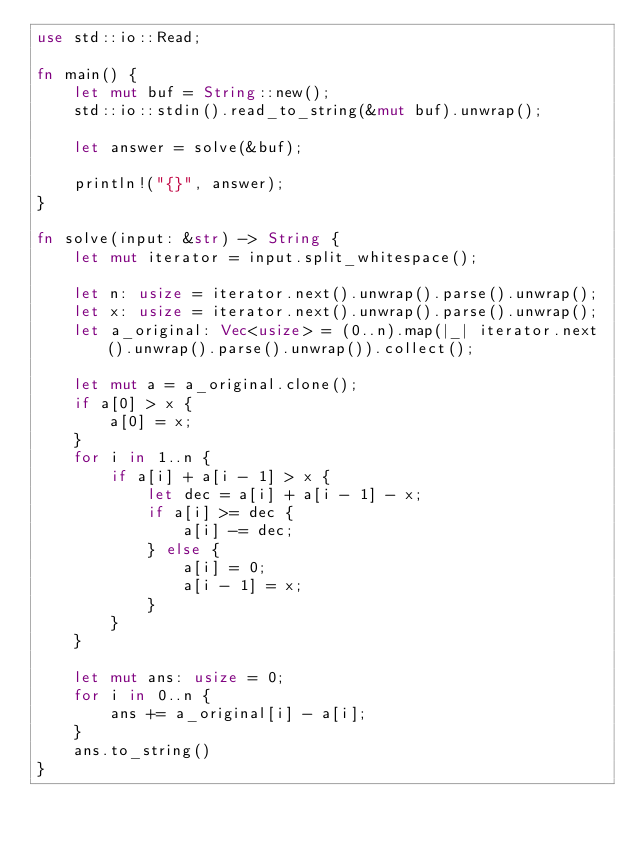Convert code to text. <code><loc_0><loc_0><loc_500><loc_500><_Rust_>use std::io::Read;

fn main() {
    let mut buf = String::new();
    std::io::stdin().read_to_string(&mut buf).unwrap();

    let answer = solve(&buf);

    println!("{}", answer);
}

fn solve(input: &str) -> String {
    let mut iterator = input.split_whitespace();

    let n: usize = iterator.next().unwrap().parse().unwrap();
    let x: usize = iterator.next().unwrap().parse().unwrap();
    let a_original: Vec<usize> = (0..n).map(|_| iterator.next().unwrap().parse().unwrap()).collect();

    let mut a = a_original.clone();
    if a[0] > x {
        a[0] = x;
    }
    for i in 1..n {
        if a[i] + a[i - 1] > x {
            let dec = a[i] + a[i - 1] - x;
            if a[i] >= dec {
                a[i] -= dec;
            } else {
                a[i] = 0;
                a[i - 1] = x;
            }
        }
    }

    let mut ans: usize = 0;
    for i in 0..n {
        ans += a_original[i] - a[i];
    }
    ans.to_string()
}
</code> 